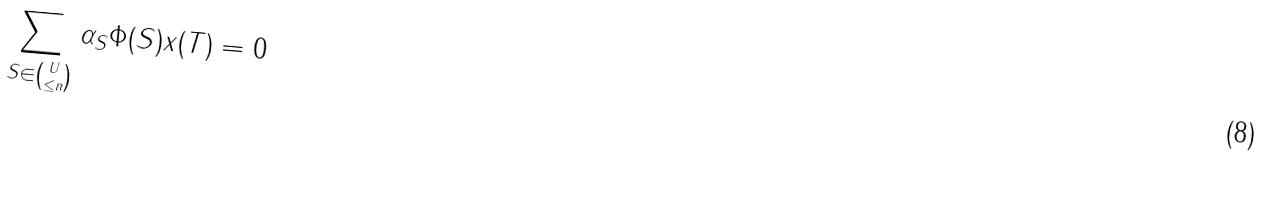Convert formula to latex. <formula><loc_0><loc_0><loc_500><loc_500>\sum _ { S \in { { U } \choose \leq n } } \alpha _ { S } \Phi ( S ) x ( T ) = 0</formula> 